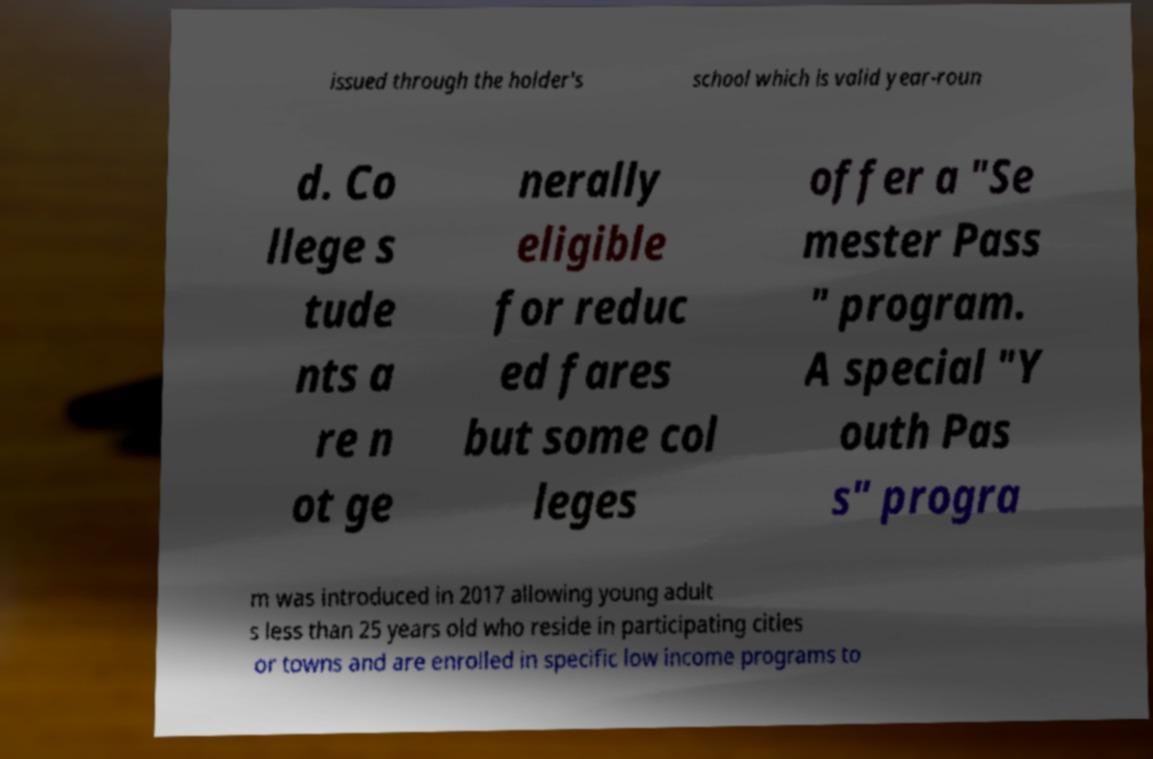There's text embedded in this image that I need extracted. Can you transcribe it verbatim? issued through the holder's school which is valid year-roun d. Co llege s tude nts a re n ot ge nerally eligible for reduc ed fares but some col leges offer a "Se mester Pass " program. A special "Y outh Pas s" progra m was introduced in 2017 allowing young adult s less than 25 years old who reside in participating cities or towns and are enrolled in specific low income programs to 